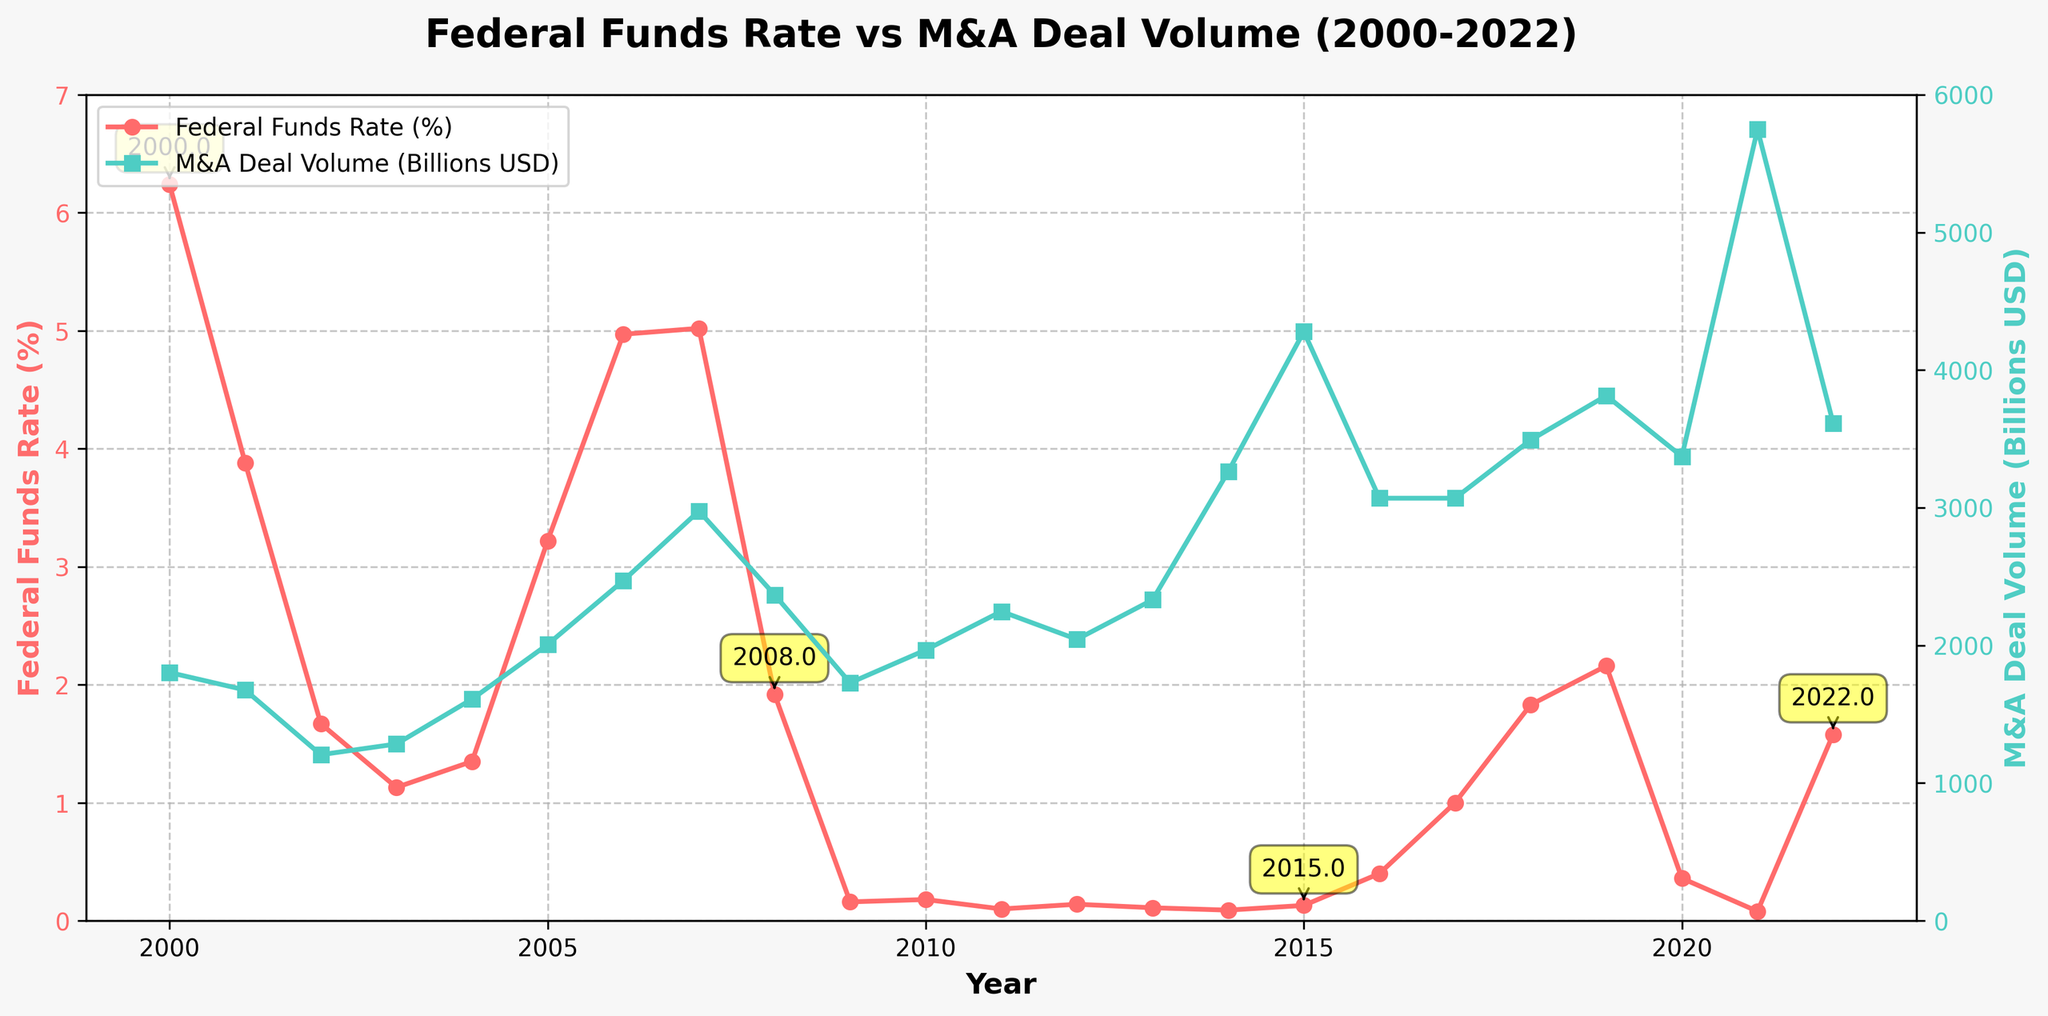Which year had the highest M&A deal volume? The green line representing M&A deal volume spikes the highest in a particular year. Follow the green markers to identify the peak, which is 2021.
Answer: 2021 How did the Federal Funds Rate change between 2000 and 2022? Observe the red line markers from 2000 to 2022. Initially, in 2000, the rate was high, then it decreased significantly until 2003, rose again, and finally fluctuated around lower values after 2008.
Answer: It decreased overall Compare the M&A deal volumes between 2008 and 2009. Which year had a higher deal volume? Look at the green line markers for 2008 and 2009. The marker for 2008 is higher than that for 2009.
Answer: 2008 What is the average Federal Funds Rate for the years that had the highest and lowest M&A deal volumes? Identify the years with the highest and lowest M&A deal volumes, which are 2021 and 2002, respectively. The Federal Funds Rates for these years are 0.08% (2021) and 1.67% (2002). Calculate the average: (0.08 + 1.67)/2.
Answer: 0.875% In which year does the Federal Funds Rate sharply drop for the first time, and how does the M&A deal volume respond? The Federal Funds Rate shows its first sharp drop around 2000 to 2001. Compare the M&A deal volume in those years. There’s a reduction in M&A deal volume from 2000 to 2001.
Answer: 2001; Reduced Compare the Federal Funds Rate and M&A deal volume between 2007 and 2008. How do they differ? Note the values for both 2007 and 2008: the Federal Funds Rate drops from 5.02% to 1.92%, while the M&A deal volume decreases from 2976 to 2368 billion USD.
Answer: Federal Funds Rate decreased, M&A deal volume decreased Which year had the closest Federal Funds Rate to 2%, and what was the corresponding M&A deal volume? Look for the year where the red line is closest to the 2% mark. The year 2002 is closest with 1.67%, and the corresponding M&A deal volume is 1206 billion USD.
Answer: 2002; 1206 billion USD What is the sum of the M&A deal volumes in 2018 and 2019? Sum the values of 2018 and 2019 from the data table or green line markers, which are 3492 and 3814 billion USD respectively: 3492 + 3814.
Answer: 7306 billion USD Which color is used to represent the Federal Funds Rate, and which one for the M&A deal volume? The lines representing each variable use distinct colors: the Federal Funds Rate is shown in red, and M&A deal volume in green.
Answer: Federal Funds Rate: red, M&A deal volume: green How do the Federal Funds Rate and M&A deal volume behave in 2015? Examine the points on the lines for the year 2015. The Federal Funds Rate is very low at 0.13%, while the M&A deal volume is higher at 4279 billion USD, indicating diverse behaviors.
Answer: Federal Funds Rate very low, M&A deal volume high 